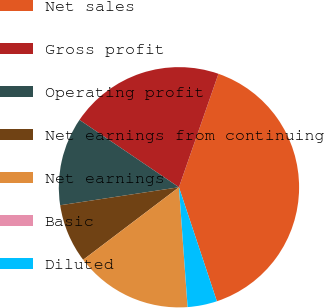Convert chart. <chart><loc_0><loc_0><loc_500><loc_500><pie_chart><fcel>Net sales<fcel>Gross profit<fcel>Operating profit<fcel>Net earnings from continuing<fcel>Net earnings<fcel>Basic<fcel>Diluted<nl><fcel>39.56%<fcel>20.86%<fcel>11.87%<fcel>7.92%<fcel>15.83%<fcel>0.01%<fcel>3.96%<nl></chart> 